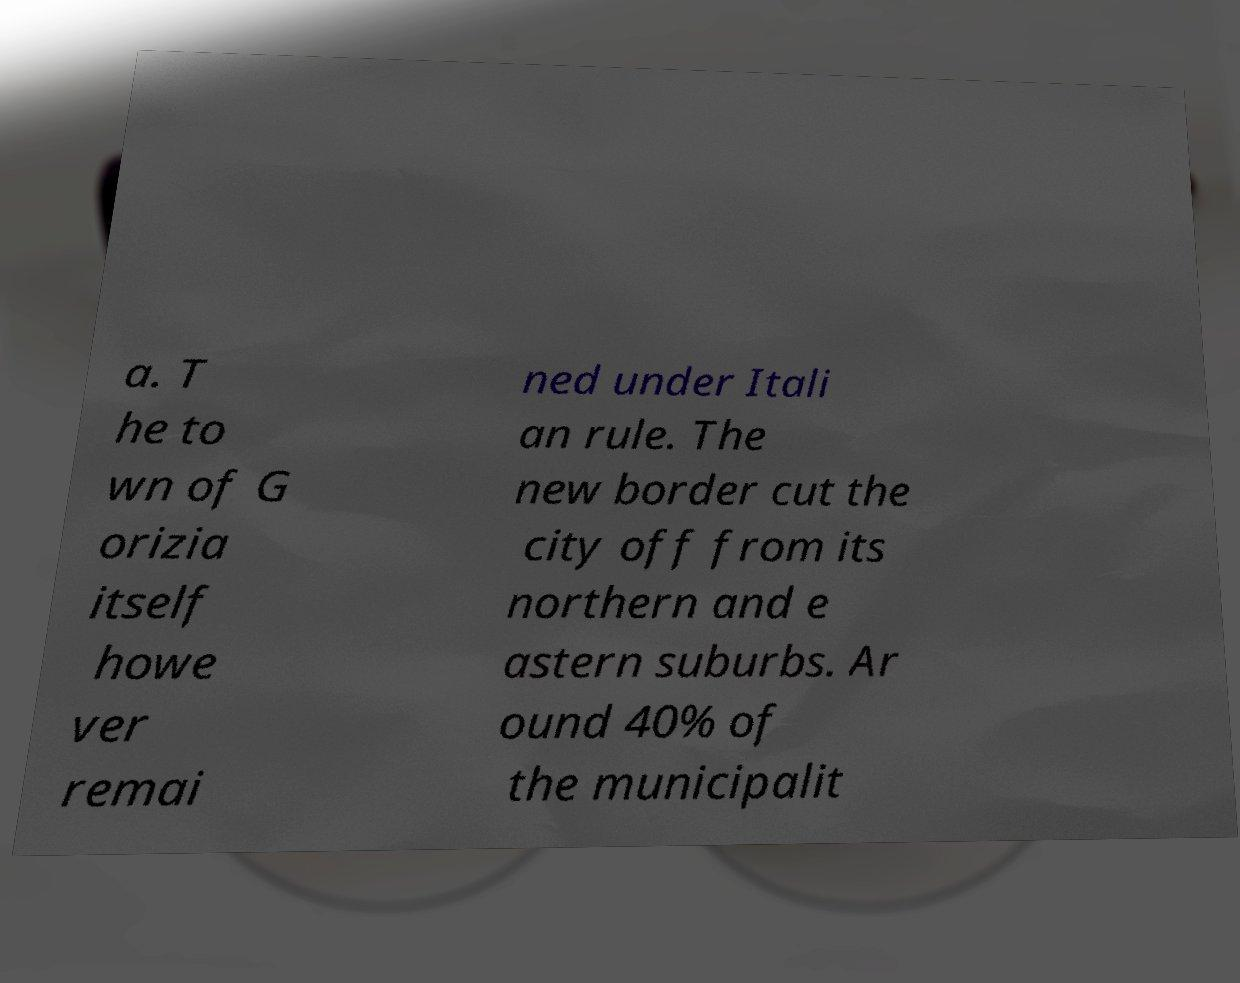Can you read and provide the text displayed in the image?This photo seems to have some interesting text. Can you extract and type it out for me? a. T he to wn of G orizia itself howe ver remai ned under Itali an rule. The new border cut the city off from its northern and e astern suburbs. Ar ound 40% of the municipalit 